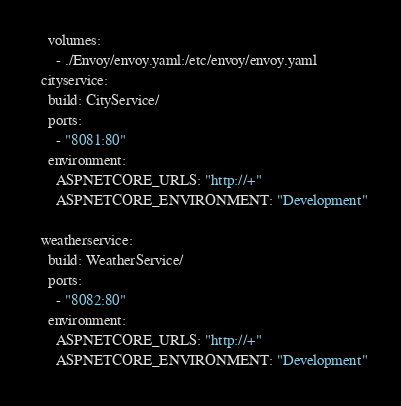<code> <loc_0><loc_0><loc_500><loc_500><_YAML_>    volumes:
      - ./Envoy/envoy.yaml:/etc/envoy/envoy.yaml
  cityservice:
    build: CityService/
    ports:
      - "8081:80"
    environment:
      ASPNETCORE_URLS: "http://+"
      ASPNETCORE_ENVIRONMENT: "Development"

  weatherservice:
    build: WeatherService/
    ports:
      - "8082:80"
    environment:
      ASPNETCORE_URLS: "http://+"
      ASPNETCORE_ENVIRONMENT: "Development"</code> 